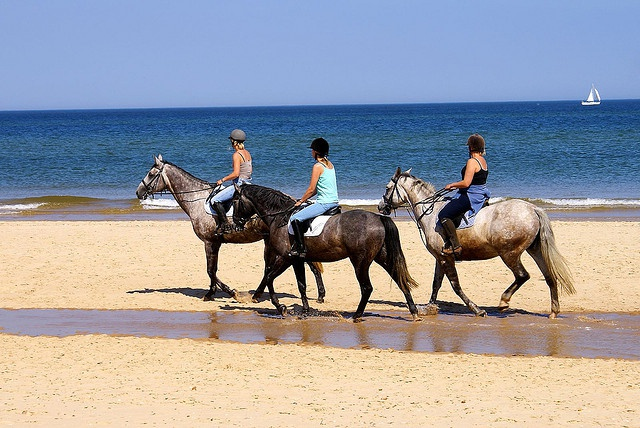Describe the objects in this image and their specific colors. I can see horse in lightblue, black, gray, maroon, and ivory tones, horse in darkgray, black, lightgray, tan, and maroon tones, horse in darkgray, black, gray, and maroon tones, people in darkgray, black, salmon, maroon, and gray tones, and people in darkgray, black, and lightblue tones in this image. 